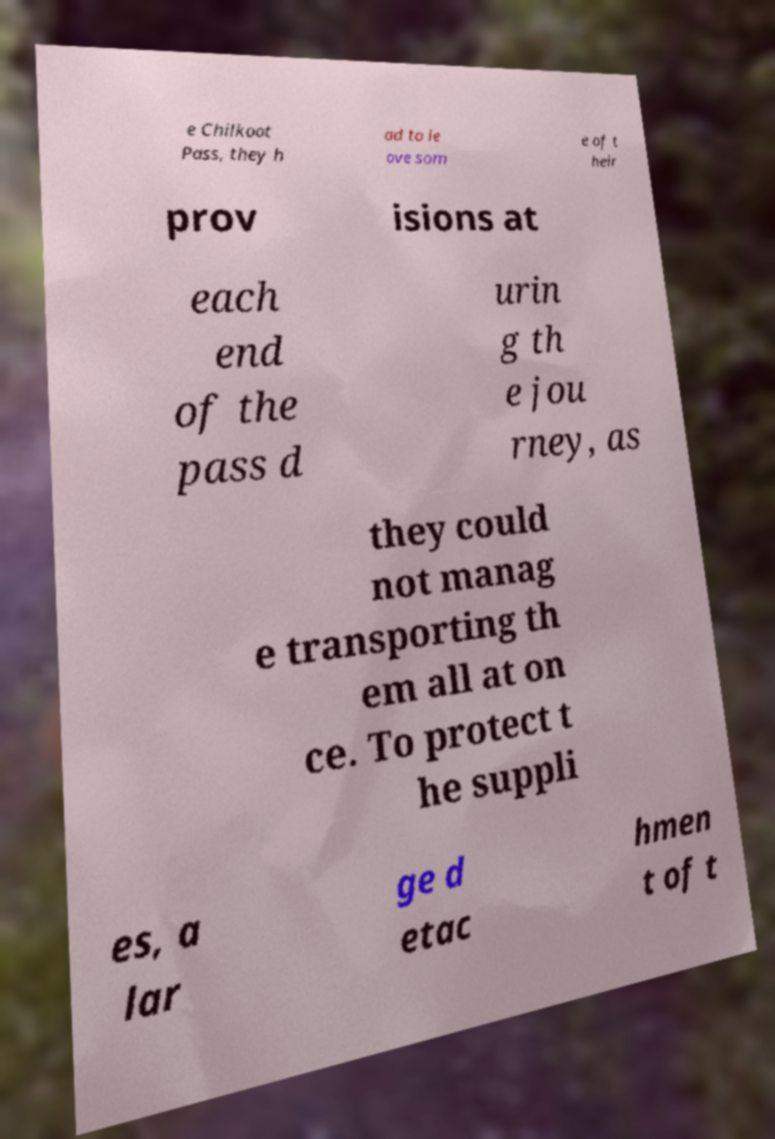Could you assist in decoding the text presented in this image and type it out clearly? e Chilkoot Pass, they h ad to le ave som e of t heir prov isions at each end of the pass d urin g th e jou rney, as they could not manag e transporting th em all at on ce. To protect t he suppli es, a lar ge d etac hmen t of t 